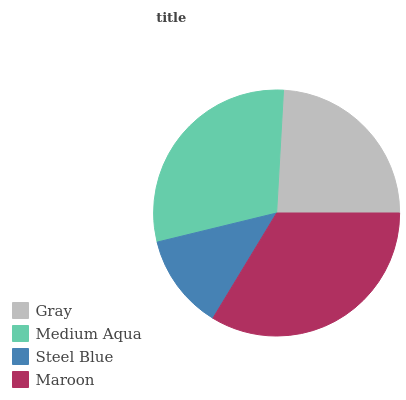Is Steel Blue the minimum?
Answer yes or no. Yes. Is Maroon the maximum?
Answer yes or no. Yes. Is Medium Aqua the minimum?
Answer yes or no. No. Is Medium Aqua the maximum?
Answer yes or no. No. Is Medium Aqua greater than Gray?
Answer yes or no. Yes. Is Gray less than Medium Aqua?
Answer yes or no. Yes. Is Gray greater than Medium Aqua?
Answer yes or no. No. Is Medium Aqua less than Gray?
Answer yes or no. No. Is Medium Aqua the high median?
Answer yes or no. Yes. Is Gray the low median?
Answer yes or no. Yes. Is Gray the high median?
Answer yes or no. No. Is Steel Blue the low median?
Answer yes or no. No. 